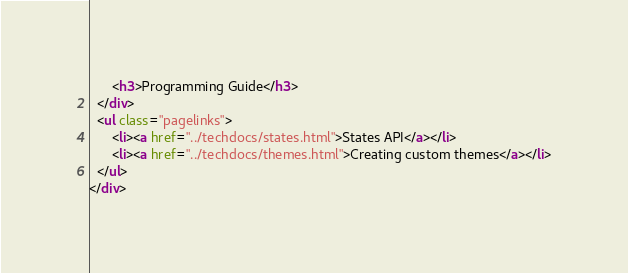<code> <loc_0><loc_0><loc_500><loc_500><_HTML_>      <h3>Programming Guide</h3>
  </div>
  <ul class="pagelinks">
      <li><a href="../techdocs/states.html">States API</a></li>
      <li><a href="../techdocs/themes.html">Creating custom themes</a></li>
  </ul>
</div>
</code> 